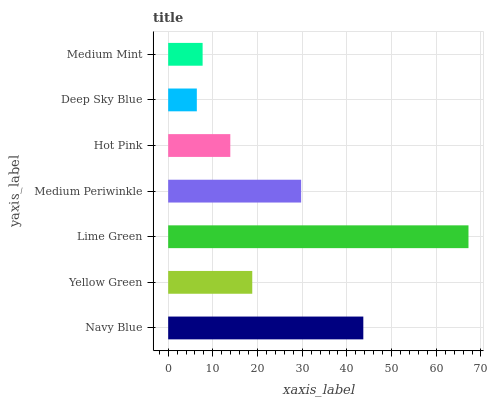Is Deep Sky Blue the minimum?
Answer yes or no. Yes. Is Lime Green the maximum?
Answer yes or no. Yes. Is Yellow Green the minimum?
Answer yes or no. No. Is Yellow Green the maximum?
Answer yes or no. No. Is Navy Blue greater than Yellow Green?
Answer yes or no. Yes. Is Yellow Green less than Navy Blue?
Answer yes or no. Yes. Is Yellow Green greater than Navy Blue?
Answer yes or no. No. Is Navy Blue less than Yellow Green?
Answer yes or no. No. Is Yellow Green the high median?
Answer yes or no. Yes. Is Yellow Green the low median?
Answer yes or no. Yes. Is Hot Pink the high median?
Answer yes or no. No. Is Medium Periwinkle the low median?
Answer yes or no. No. 